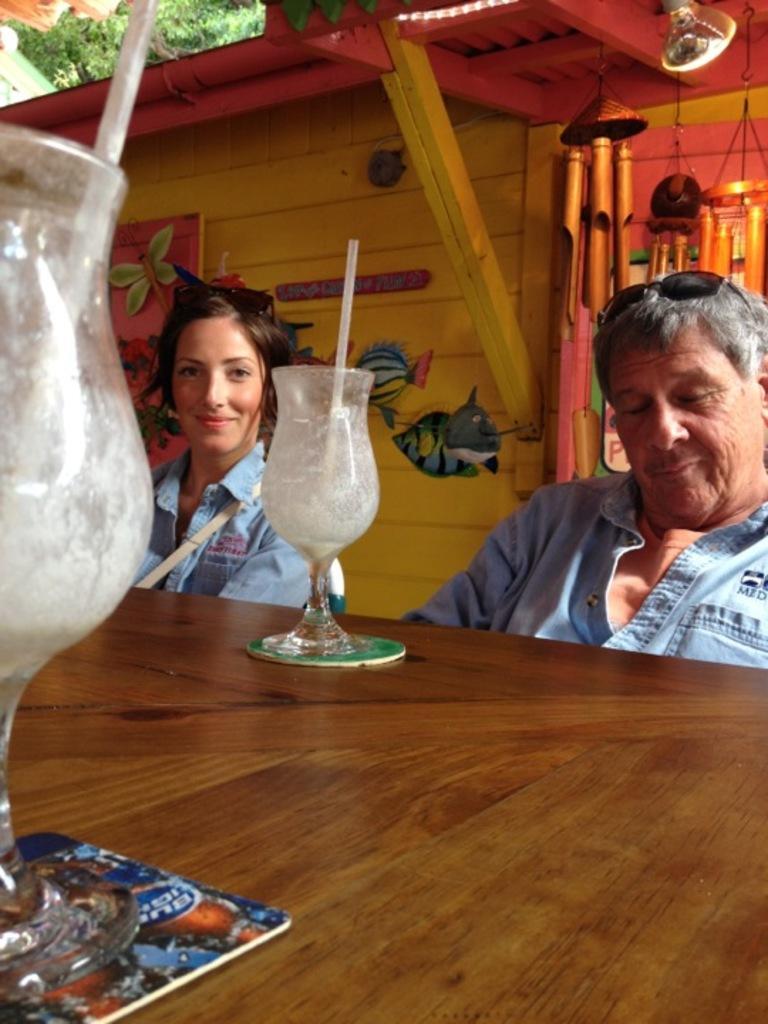Please provide a concise description of this image. There is a person wearing blue shirt and goggles. A lady wearing a blue shirt is smiling. There is a table. On the table there is a tray and two glasses with straw. In the background there is a wall with paintings. 